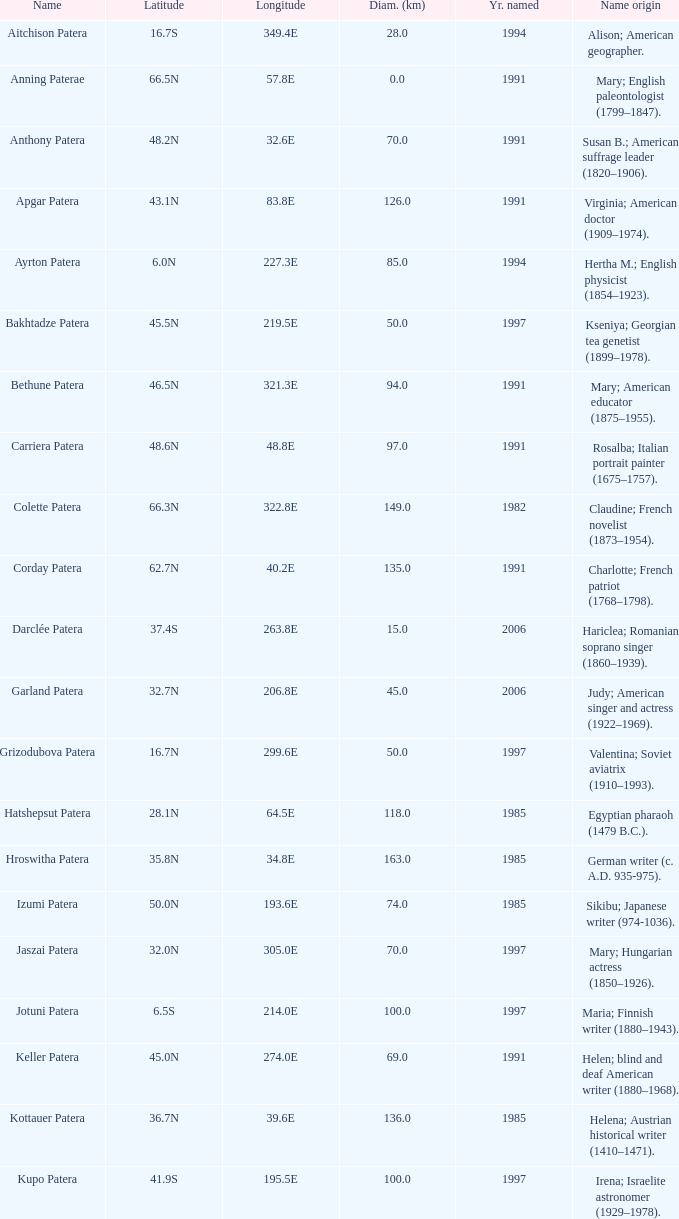What is the longitude of the feature named Razia Patera?  197.8E. 